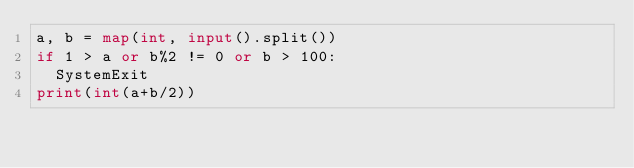Convert code to text. <code><loc_0><loc_0><loc_500><loc_500><_Python_>a, b = map(int, input().split())
if 1 > a or b%2 != 0 or b > 100:
  SystemExit
print(int(a+b/2))</code> 